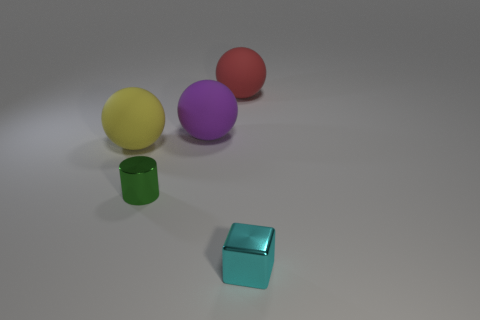Add 1 tiny gray spheres. How many objects exist? 6 Subtract all balls. How many objects are left? 2 Subtract 0 gray balls. How many objects are left? 5 Subtract all tiny purple cylinders. Subtract all large purple matte objects. How many objects are left? 4 Add 3 yellow things. How many yellow things are left? 4 Add 5 tiny green shiny things. How many tiny green shiny things exist? 6 